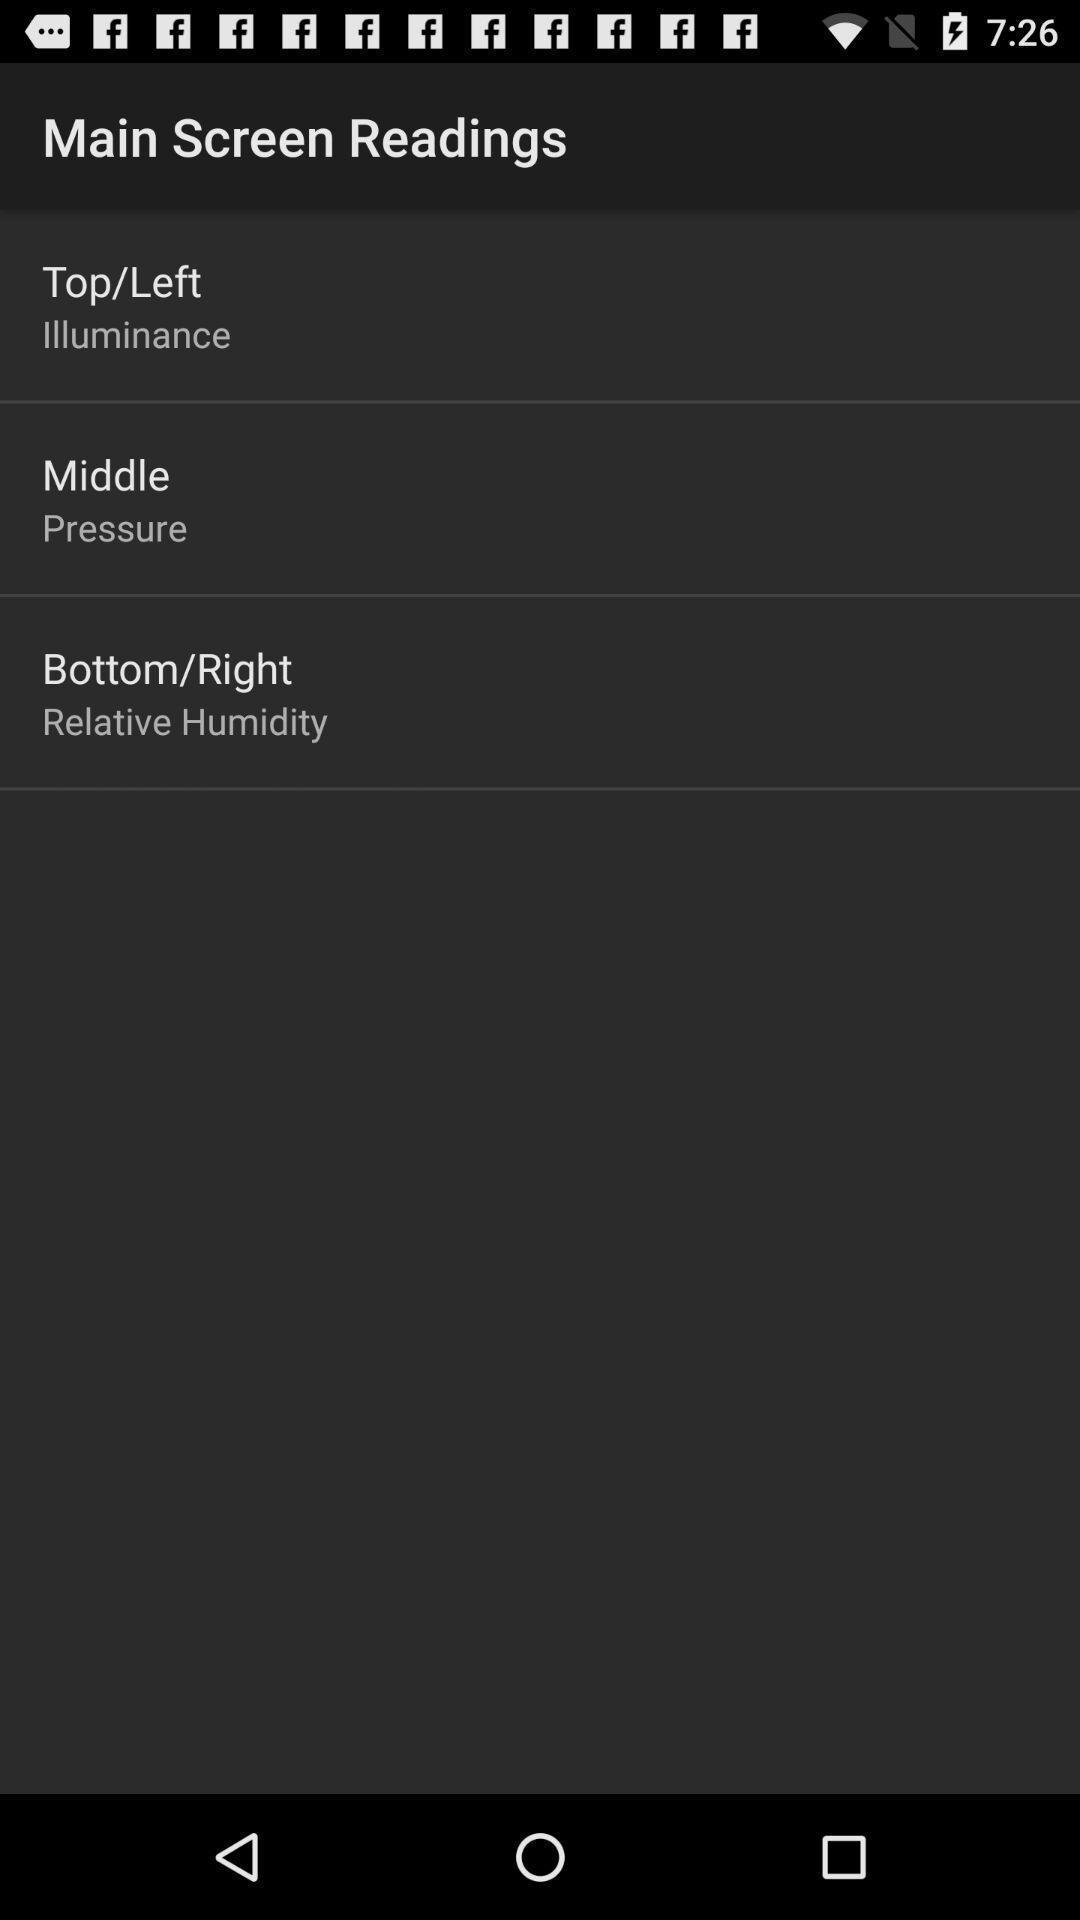Please provide a description for this image. Window displaying page for screen readings. 